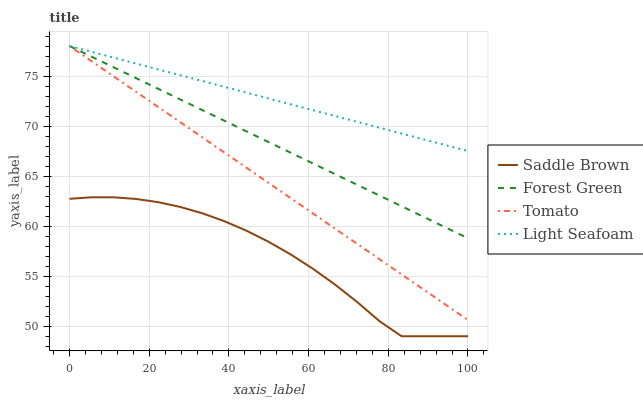Does Saddle Brown have the minimum area under the curve?
Answer yes or no. Yes. Does Light Seafoam have the maximum area under the curve?
Answer yes or no. Yes. Does Forest Green have the minimum area under the curve?
Answer yes or no. No. Does Forest Green have the maximum area under the curve?
Answer yes or no. No. Is Forest Green the smoothest?
Answer yes or no. Yes. Is Saddle Brown the roughest?
Answer yes or no. Yes. Is Light Seafoam the smoothest?
Answer yes or no. No. Is Light Seafoam the roughest?
Answer yes or no. No. Does Saddle Brown have the lowest value?
Answer yes or no. Yes. Does Forest Green have the lowest value?
Answer yes or no. No. Does Light Seafoam have the highest value?
Answer yes or no. Yes. Does Saddle Brown have the highest value?
Answer yes or no. No. Is Saddle Brown less than Tomato?
Answer yes or no. Yes. Is Tomato greater than Saddle Brown?
Answer yes or no. Yes. Does Forest Green intersect Tomato?
Answer yes or no. Yes. Is Forest Green less than Tomato?
Answer yes or no. No. Is Forest Green greater than Tomato?
Answer yes or no. No. Does Saddle Brown intersect Tomato?
Answer yes or no. No. 